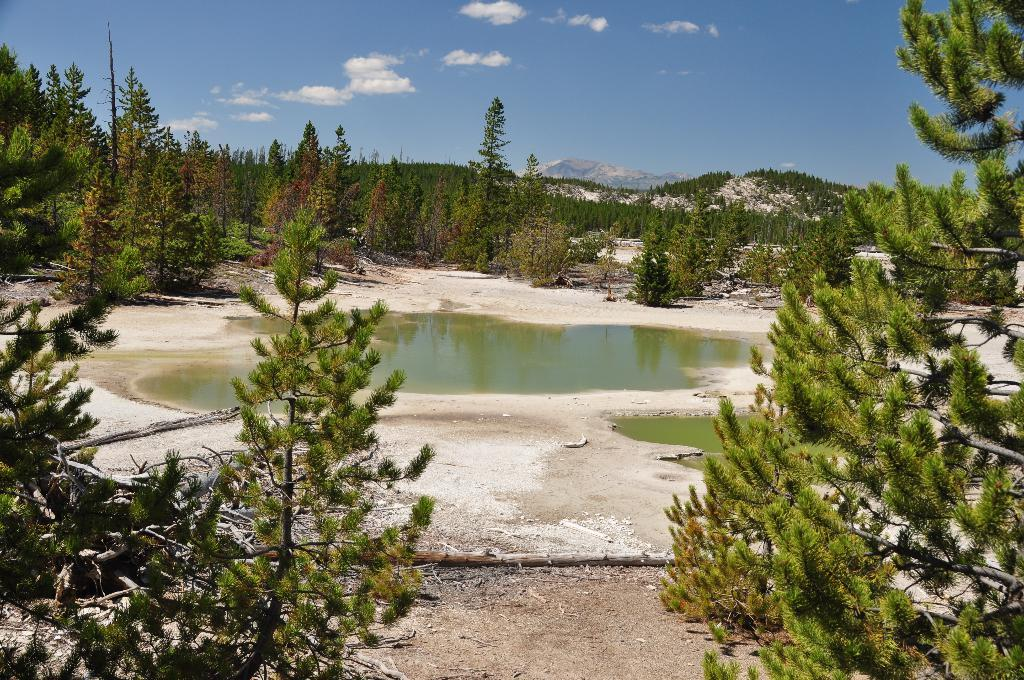What is the main feature of the image? There is a small pond with water in the image. What can be seen around the pond? There are trees with branches and leaves in the image. What is visible in the distance in the image? There are mountains visible in the background of the image. What is the condition of the sky in the image? Clouds are present in the sky in the image. How many legs can be seen on the chickens in the image? There are no chickens present in the image, so the number of legs cannot be determined. 